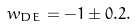<formula> <loc_0><loc_0><loc_500><loc_500>w _ { D E } = - 1 \pm 0 . 2 .</formula> 